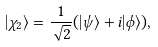<formula> <loc_0><loc_0><loc_500><loc_500>| \chi _ { 2 } \rangle = \frac { 1 } { \sqrt { 2 } } ( | \psi \rangle + i | \phi \rangle ) ,</formula> 